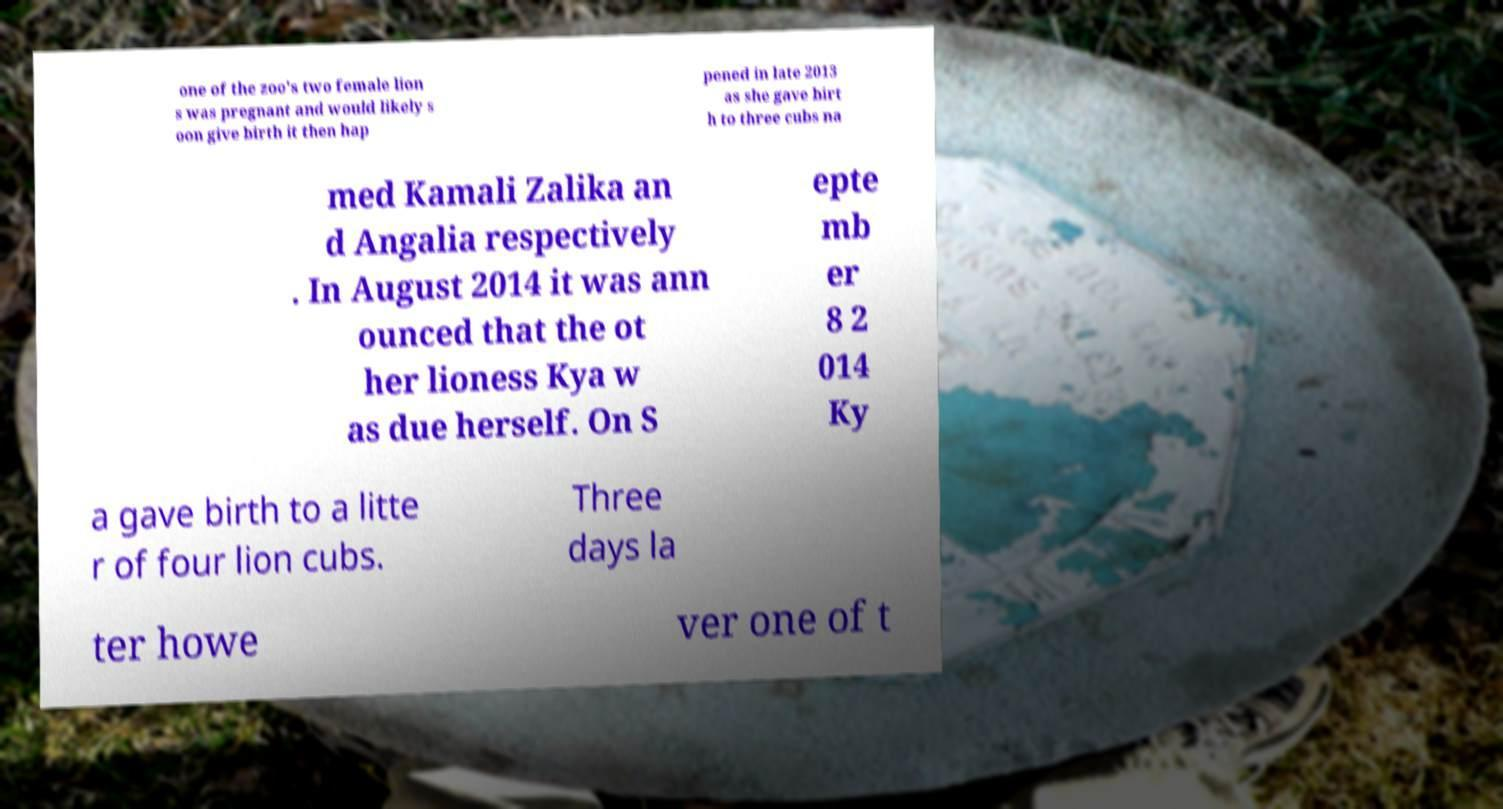For documentation purposes, I need the text within this image transcribed. Could you provide that? one of the zoo's two female lion s was pregnant and would likely s oon give birth it then hap pened in late 2013 as she gave birt h to three cubs na med Kamali Zalika an d Angalia respectively . In August 2014 it was ann ounced that the ot her lioness Kya w as due herself. On S epte mb er 8 2 014 Ky a gave birth to a litte r of four lion cubs. Three days la ter howe ver one of t 